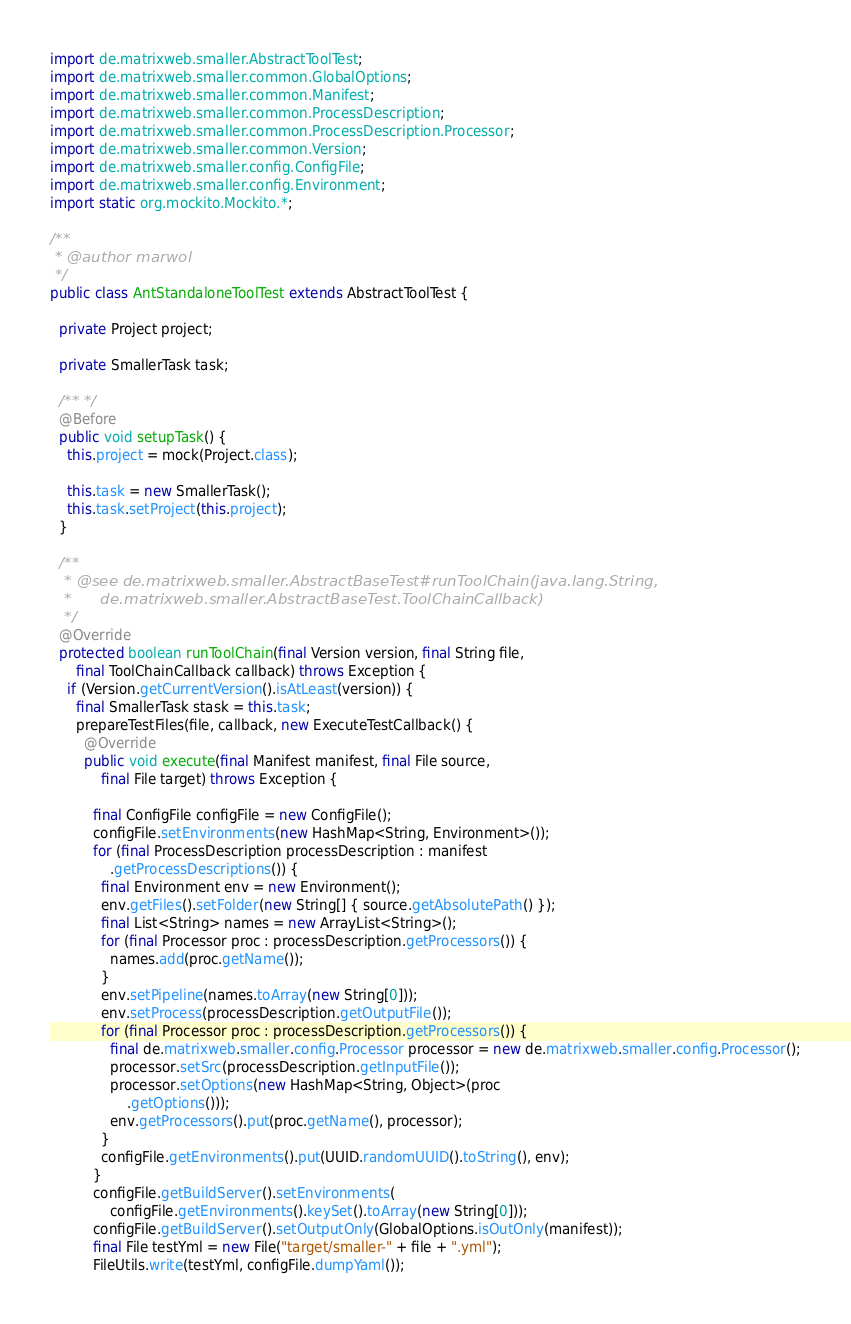<code> <loc_0><loc_0><loc_500><loc_500><_Java_>import de.matrixweb.smaller.AbstractToolTest;
import de.matrixweb.smaller.common.GlobalOptions;
import de.matrixweb.smaller.common.Manifest;
import de.matrixweb.smaller.common.ProcessDescription;
import de.matrixweb.smaller.common.ProcessDescription.Processor;
import de.matrixweb.smaller.common.Version;
import de.matrixweb.smaller.config.ConfigFile;
import de.matrixweb.smaller.config.Environment;
import static org.mockito.Mockito.*;

/**
 * @author marwol
 */
public class AntStandaloneToolTest extends AbstractToolTest {

  private Project project;

  private SmallerTask task;

  /** */
  @Before
  public void setupTask() {
    this.project = mock(Project.class);

    this.task = new SmallerTask();
    this.task.setProject(this.project);
  }

  /**
   * @see de.matrixweb.smaller.AbstractBaseTest#runToolChain(java.lang.String,
   *      de.matrixweb.smaller.AbstractBaseTest.ToolChainCallback)
   */
  @Override
  protected boolean runToolChain(final Version version, final String file,
      final ToolChainCallback callback) throws Exception {
    if (Version.getCurrentVersion().isAtLeast(version)) {
      final SmallerTask stask = this.task;
      prepareTestFiles(file, callback, new ExecuteTestCallback() {
        @Override
        public void execute(final Manifest manifest, final File source,
            final File target) throws Exception {

          final ConfigFile configFile = new ConfigFile();
          configFile.setEnvironments(new HashMap<String, Environment>());
          for (final ProcessDescription processDescription : manifest
              .getProcessDescriptions()) {
            final Environment env = new Environment();
            env.getFiles().setFolder(new String[] { source.getAbsolutePath() });
            final List<String> names = new ArrayList<String>();
            for (final Processor proc : processDescription.getProcessors()) {
              names.add(proc.getName());
            }
            env.setPipeline(names.toArray(new String[0]));
            env.setProcess(processDescription.getOutputFile());
            for (final Processor proc : processDescription.getProcessors()) {
              final de.matrixweb.smaller.config.Processor processor = new de.matrixweb.smaller.config.Processor();
              processor.setSrc(processDescription.getInputFile());
              processor.setOptions(new HashMap<String, Object>(proc
                  .getOptions()));
              env.getProcessors().put(proc.getName(), processor);
            }
            configFile.getEnvironments().put(UUID.randomUUID().toString(), env);
          }
          configFile.getBuildServer().setEnvironments(
              configFile.getEnvironments().keySet().toArray(new String[0]));
          configFile.getBuildServer().setOutputOnly(GlobalOptions.isOutOnly(manifest));
          final File testYml = new File("target/smaller-" + file + ".yml");
          FileUtils.write(testYml, configFile.dumpYaml());
</code> 